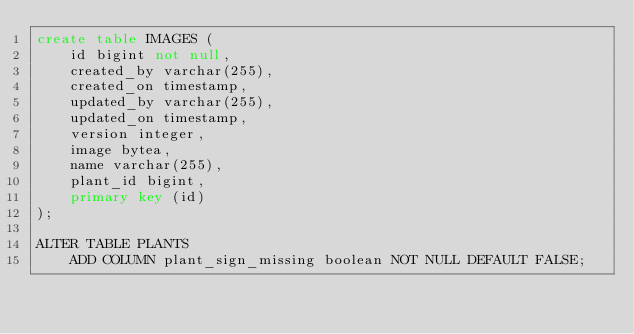<code> <loc_0><loc_0><loc_500><loc_500><_SQL_>create table IMAGES (
    id bigint not null,
    created_by varchar(255),
    created_on timestamp,
    updated_by varchar(255),
    updated_on timestamp,
    version integer,
    image bytea,
    name varchar(255),
    plant_id bigint,
    primary key (id)
);

ALTER TABLE PLANTS
    ADD COLUMN plant_sign_missing boolean NOT NULL DEFAULT FALSE;
</code> 